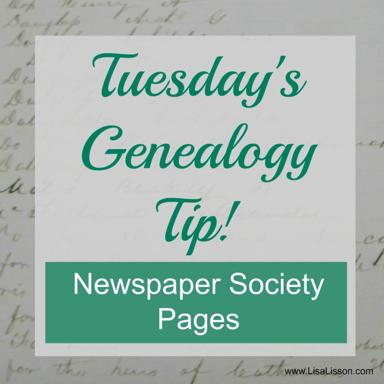What is the subject of the Tuesday Genealogy Tip mentioned in the image? The subject of the Tuesday Genealogy Tip shown in the image is focused on 'Newspaper Society Pages.' This tip likely suggests using society pages, found in newspapers, as valuable resources for genealogical research to uncover detailed personal and social information about ancestors. 